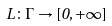<formula> <loc_0><loc_0><loc_500><loc_500>L \colon \Gamma \rightarrow [ 0 , + \infty ]</formula> 